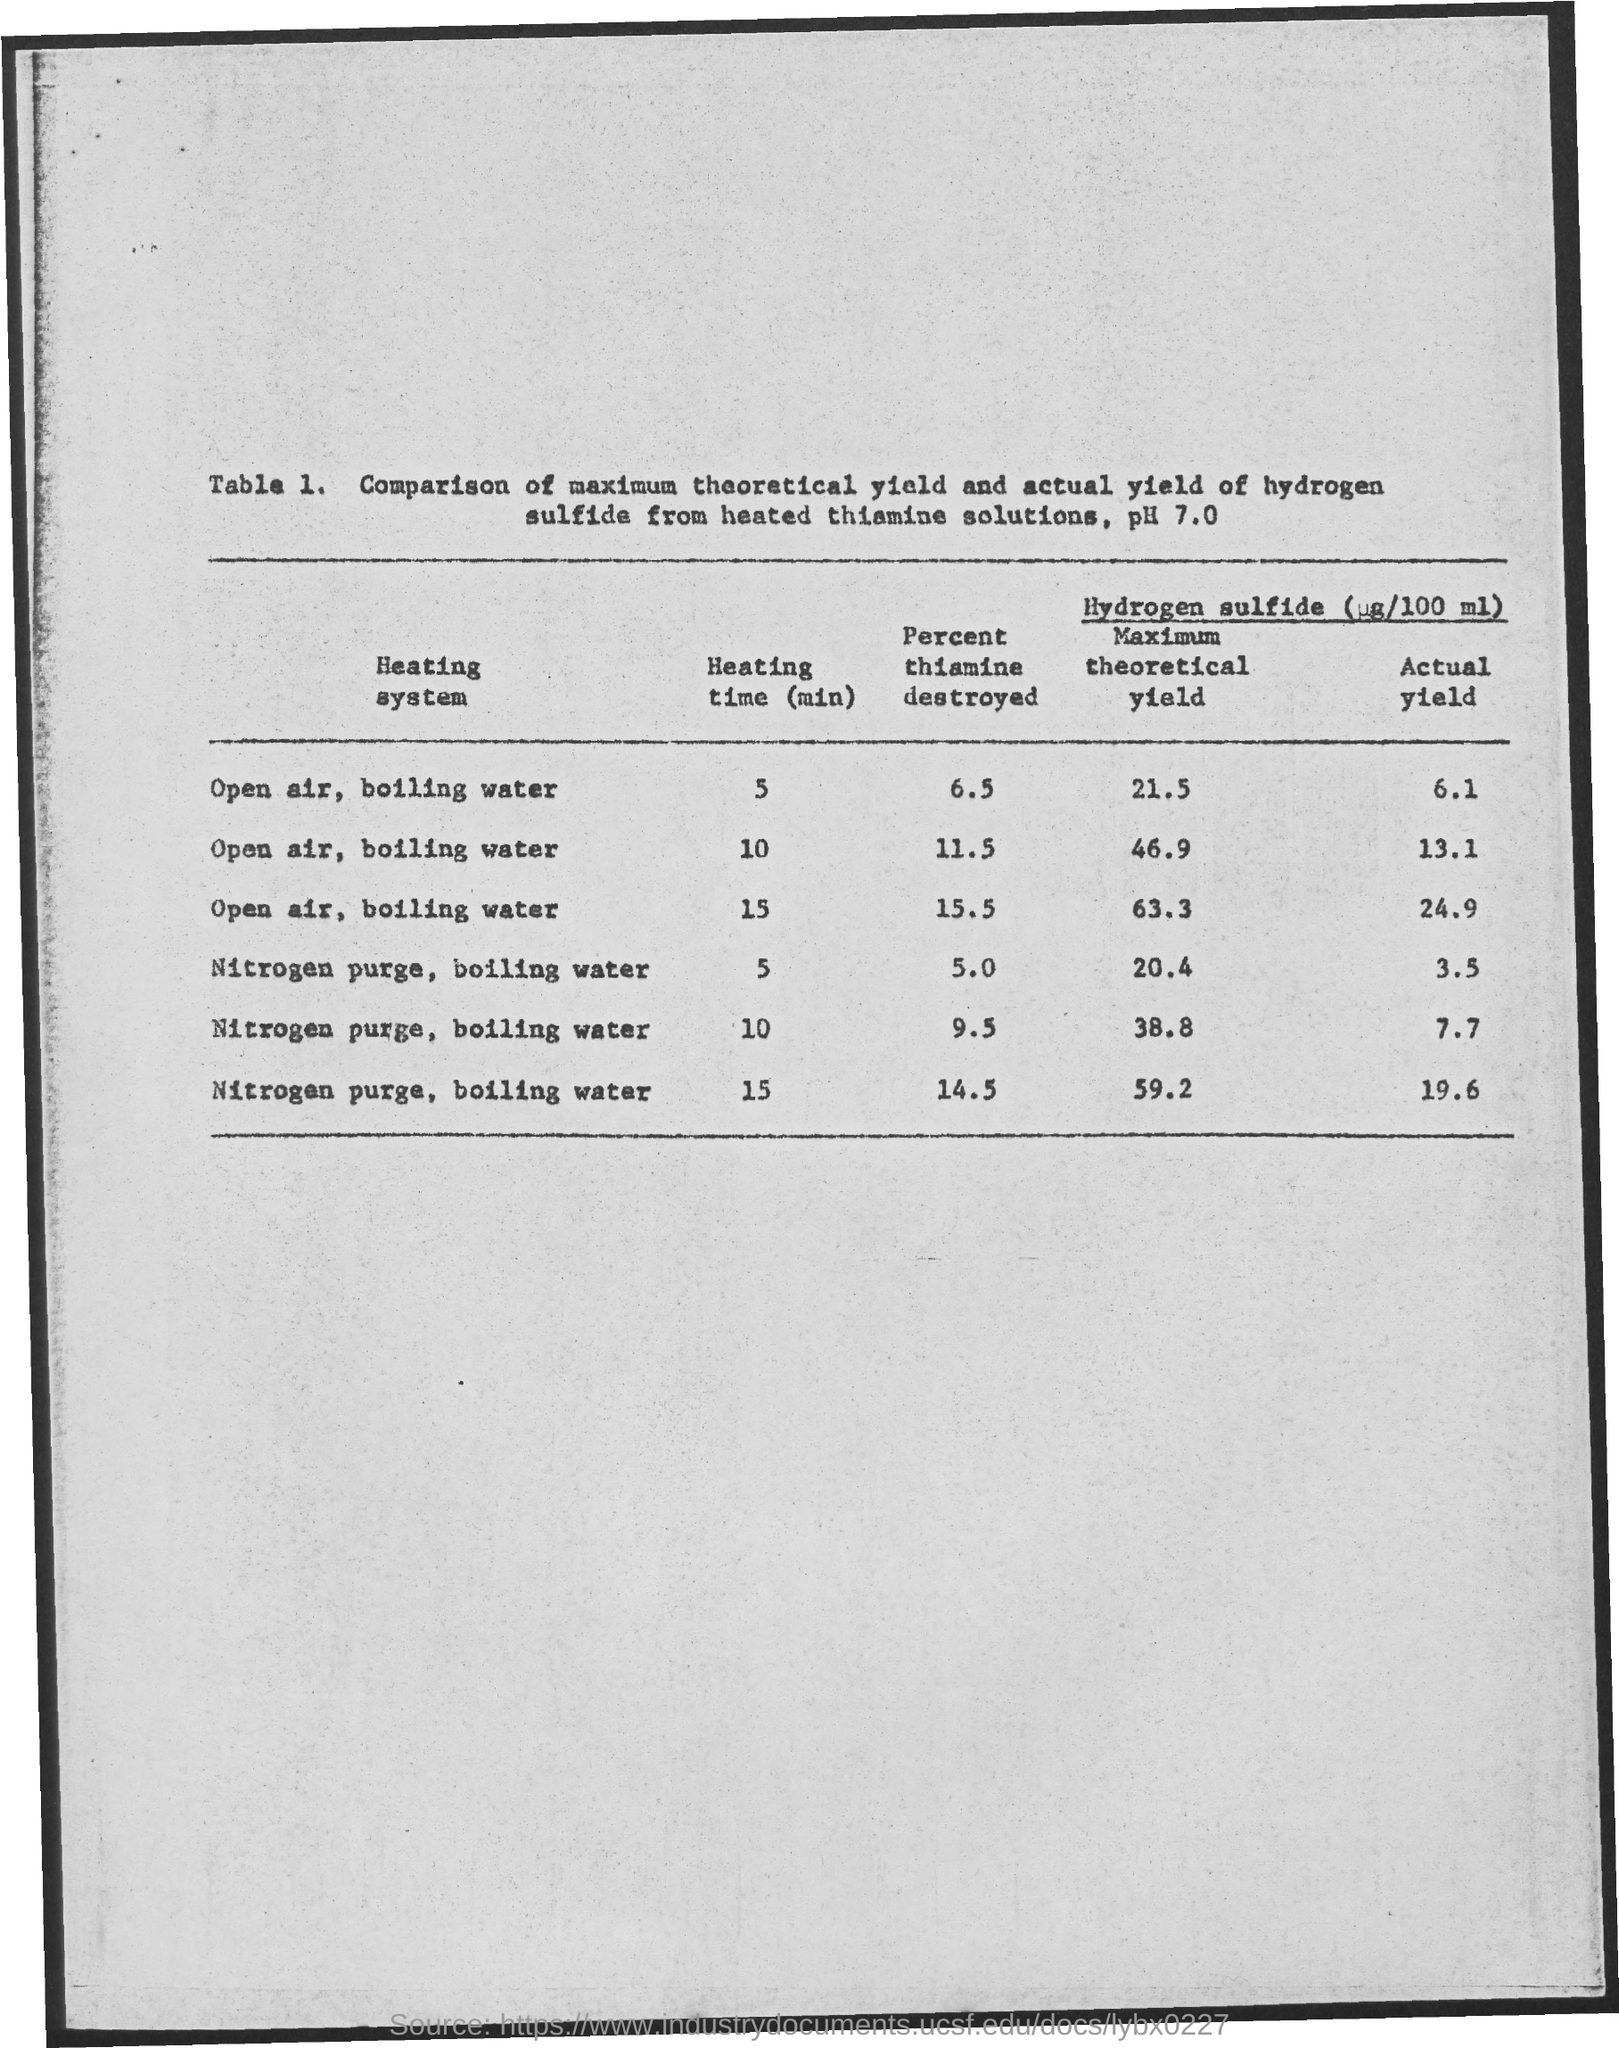In the heating system of open air, boiling water what percent of thiamine is destroyed for the heating time of 5min ?
Your answer should be compact. 6.5. In the heating system of open air, boiling water what percent of thiamine is destroyed for the heating time of 15 min ?
Provide a short and direct response. 15.5. In the heating system of open air, boiling water what percent of thiamine is destroyed for the heating time of 10 min ?
Ensure brevity in your answer.  11.5. In the heating system of nitrogen purge, boiling water what percent of thiamine is destroyed for the heating time of 15 min ?
Provide a short and direct response. 14.5. For open air,boiling water what is the maximum theoretical yield value for the heating time of 5min ?
Ensure brevity in your answer.  21.5. What is the actual yield value for the heating time of 10 mins in heating system of nitrogen purge,boiling water ?
Your response must be concise. 7.7. 